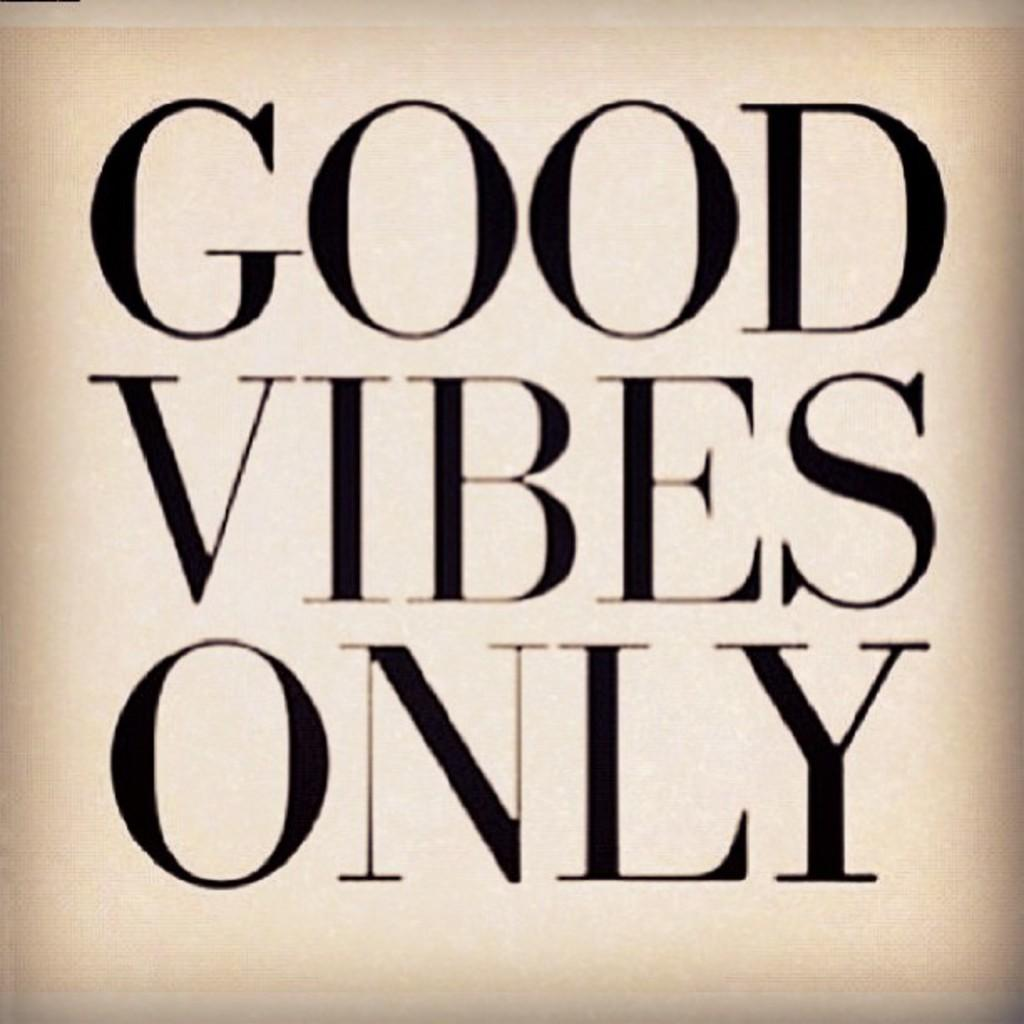<image>
Share a concise interpretation of the image provided. A poster has the phrase "good vibes only" written on it. 